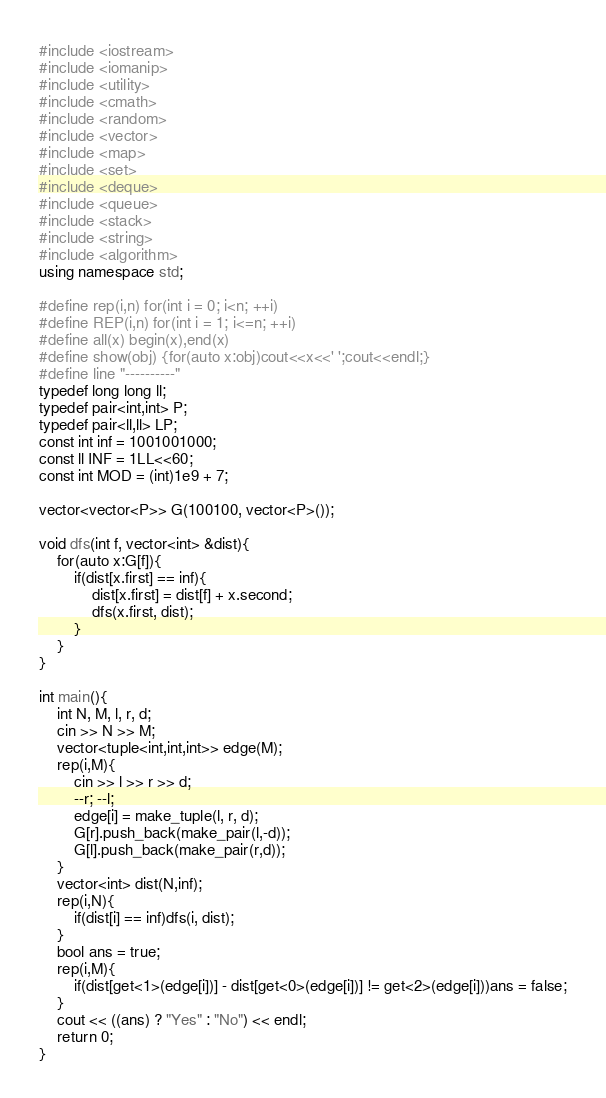Convert code to text. <code><loc_0><loc_0><loc_500><loc_500><_C++_>#include <iostream>
#include <iomanip>
#include <utility>
#include <cmath>
#include <random>
#include <vector>
#include <map>
#include <set>
#include <deque>
#include <queue>
#include <stack>
#include <string>
#include <algorithm>
using namespace std;

#define rep(i,n) for(int i = 0; i<n; ++i)
#define REP(i,n) for(int i = 1; i<=n; ++i)
#define all(x) begin(x),end(x)
#define show(obj) {for(auto x:obj)cout<<x<<' ';cout<<endl;}
#define line "----------"
typedef long long ll;
typedef pair<int,int> P;
typedef pair<ll,ll> LP;
const int inf = 1001001000;
const ll INF = 1LL<<60;
const int MOD = (int)1e9 + 7;

vector<vector<P>> G(100100, vector<P>());

void dfs(int f, vector<int> &dist){
	for(auto x:G[f]){
		if(dist[x.first] == inf){
			dist[x.first] = dist[f] + x.second;
			dfs(x.first, dist);
		}
	}
}

int main(){
	int N, M, l, r, d;
	cin >> N >> M;
	vector<tuple<int,int,int>> edge(M);
	rep(i,M){
		cin >> l >> r >> d;
		--r; --l;
		edge[i] = make_tuple(l, r, d);
		G[r].push_back(make_pair(l,-d));
		G[l].push_back(make_pair(r,d));
	}
	vector<int> dist(N,inf);
	rep(i,N){
		if(dist[i] == inf)dfs(i, dist);
	}
	bool ans = true;
	rep(i,M){
		if(dist[get<1>(edge[i])] - dist[get<0>(edge[i])] != get<2>(edge[i]))ans = false;
	}
	cout << ((ans) ? "Yes" : "No") << endl;
	return 0;
}
</code> 